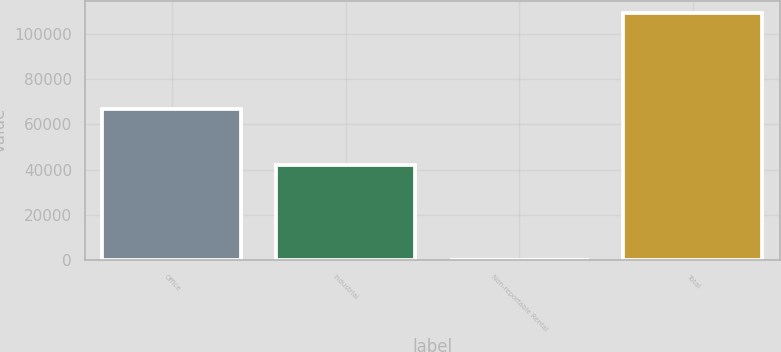Convert chart. <chart><loc_0><loc_0><loc_500><loc_500><bar_chart><fcel>Office<fcel>Industrial<fcel>Non-reportable Rental<fcel>Total<nl><fcel>66890<fcel>42083<fcel>67<fcel>109040<nl></chart> 